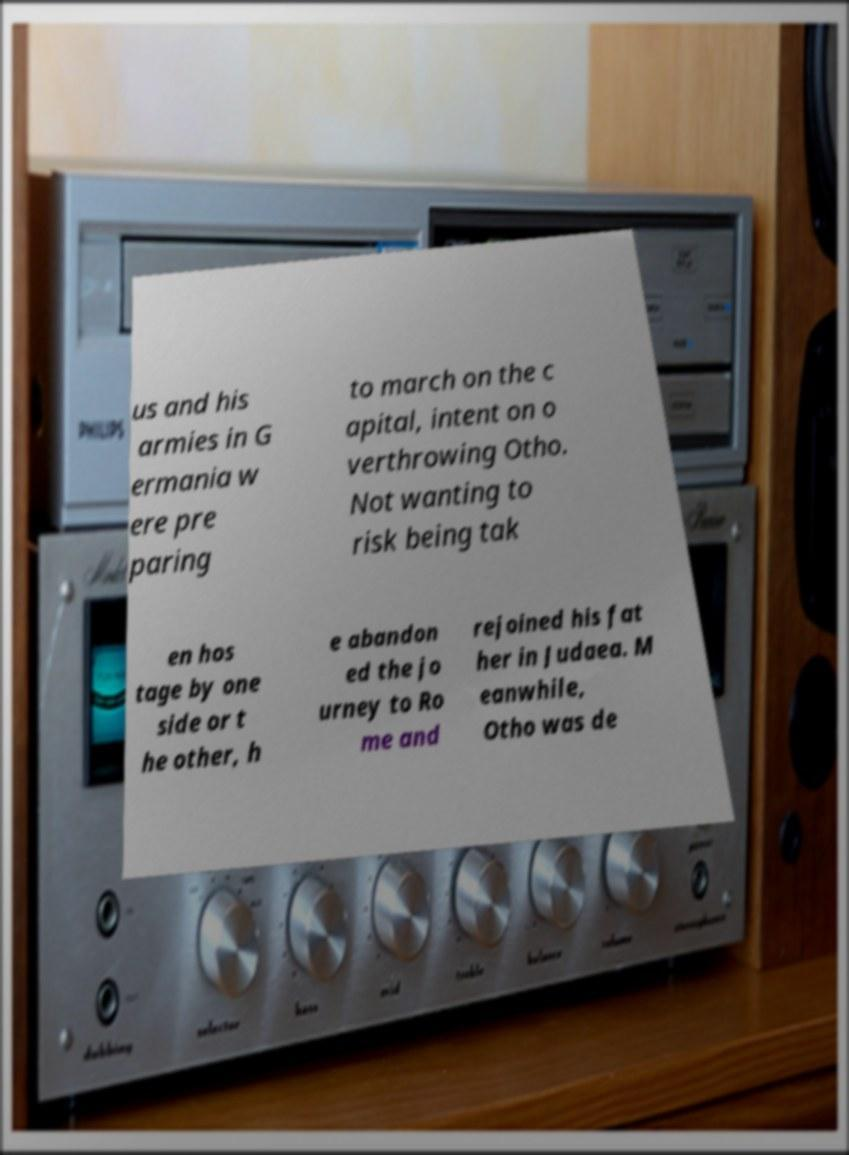For documentation purposes, I need the text within this image transcribed. Could you provide that? us and his armies in G ermania w ere pre paring to march on the c apital, intent on o verthrowing Otho. Not wanting to risk being tak en hos tage by one side or t he other, h e abandon ed the jo urney to Ro me and rejoined his fat her in Judaea. M eanwhile, Otho was de 